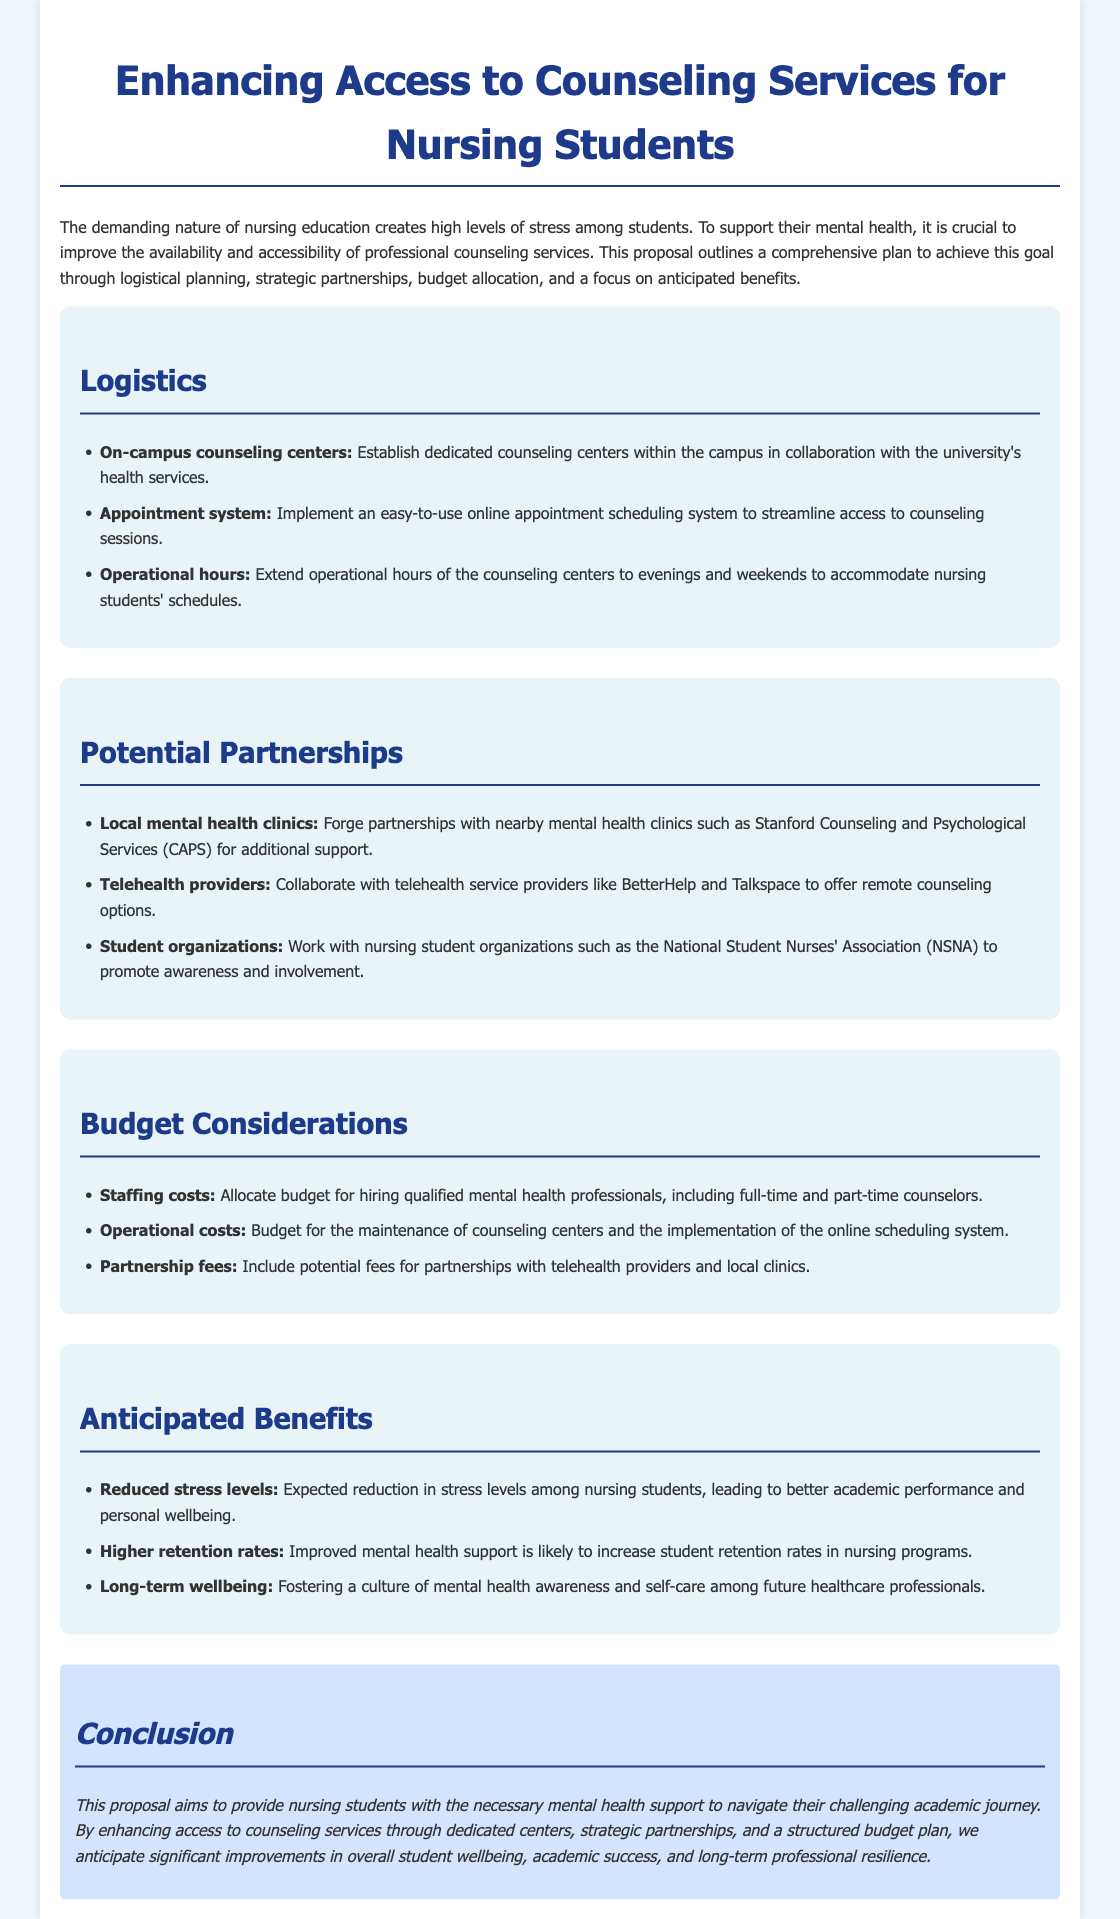What is the title of the proposal? The title of the proposal is prominently displayed at the top of the document, which provides a clear indication of the content and purpose of the proposal.
Answer: Enhancing Access to Counseling Services for Nursing Students What is one potential partnership mentioned? The proposal lists potential partnerships that are essential for enhancing counseling services, providing specific examples of organizations or entities involved.
Answer: Local mental health clinics How many operational hours are recommended for counseling centers? The document states the recommended operational hours for the counseling centers to best suit nursing students’ schedules, indicating a consideration for their availability.
Answer: Evenings and weekends What is one anticipated benefit of improved counseling services? The anticipated benefits are listed to show the positive outcomes expected from the proposal, focusing on students' overall health and academic performance.
Answer: Reduced stress levels What type of appointment system is proposed? The proposal outlines a specific system to facilitate student access to counseling services, addressing logistics and ease of use.
Answer: Online appointment scheduling system How will the proposal contribute to retention rates? The proposal implies that through various means of support, improved mental health services are expected to have a positive impact on the persistence of students in the nursing program.
Answer: Higher retention rates 